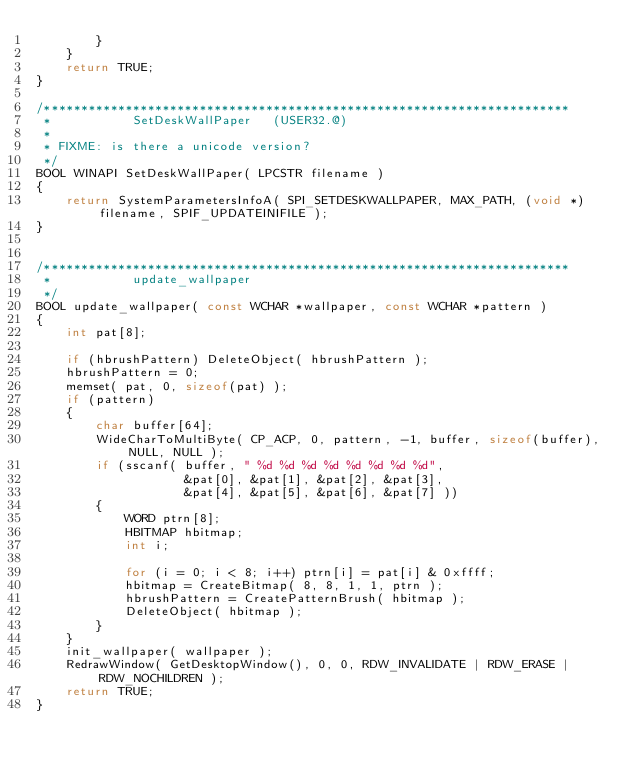<code> <loc_0><loc_0><loc_500><loc_500><_C_>        }
    }
    return TRUE;
}

/***********************************************************************
 *           SetDeskWallPaper   (USER32.@)
 *
 * FIXME: is there a unicode version?
 */
BOOL WINAPI SetDeskWallPaper( LPCSTR filename )
{
    return SystemParametersInfoA( SPI_SETDESKWALLPAPER, MAX_PATH, (void *)filename, SPIF_UPDATEINIFILE );
}


/***********************************************************************
 *           update_wallpaper
 */
BOOL update_wallpaper( const WCHAR *wallpaper, const WCHAR *pattern )
{
    int pat[8];

    if (hbrushPattern) DeleteObject( hbrushPattern );
    hbrushPattern = 0;
    memset( pat, 0, sizeof(pat) );
    if (pattern)
    {
        char buffer[64];
        WideCharToMultiByte( CP_ACP, 0, pattern, -1, buffer, sizeof(buffer), NULL, NULL );
        if (sscanf( buffer, " %d %d %d %d %d %d %d %d",
                    &pat[0], &pat[1], &pat[2], &pat[3],
                    &pat[4], &pat[5], &pat[6], &pat[7] ))
        {
            WORD ptrn[8];
            HBITMAP hbitmap;
            int i;

            for (i = 0; i < 8; i++) ptrn[i] = pat[i] & 0xffff;
            hbitmap = CreateBitmap( 8, 8, 1, 1, ptrn );
            hbrushPattern = CreatePatternBrush( hbitmap );
            DeleteObject( hbitmap );
        }
    }
    init_wallpaper( wallpaper );
    RedrawWindow( GetDesktopWindow(), 0, 0, RDW_INVALIDATE | RDW_ERASE | RDW_NOCHILDREN );
    return TRUE;
}
</code> 